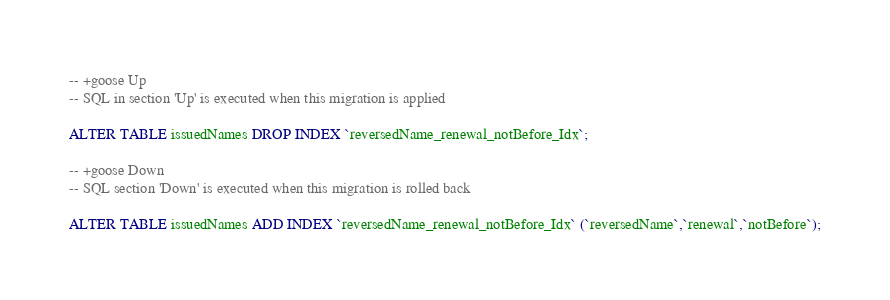<code> <loc_0><loc_0><loc_500><loc_500><_SQL_>-- +goose Up
-- SQL in section 'Up' is executed when this migration is applied

ALTER TABLE issuedNames DROP INDEX `reversedName_renewal_notBefore_Idx`;

-- +goose Down
-- SQL section 'Down' is executed when this migration is rolled back

ALTER TABLE issuedNames ADD INDEX `reversedName_renewal_notBefore_Idx` (`reversedName`,`renewal`,`notBefore`);
</code> 